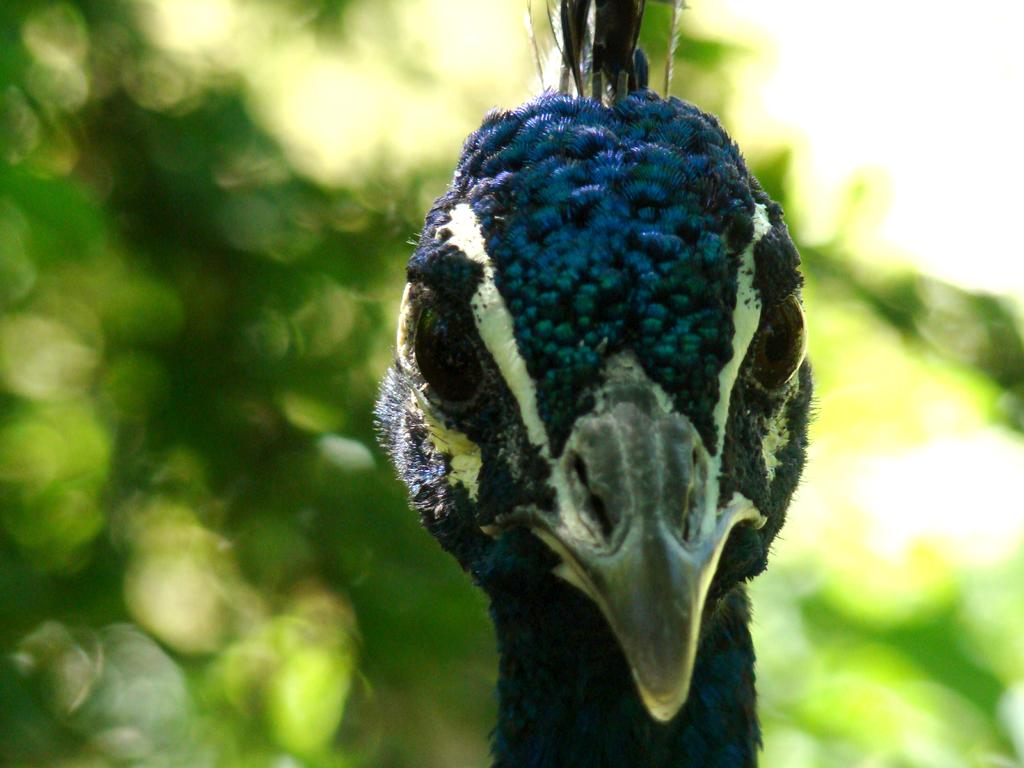What is the main subject of the image? The main subject of the image is a bird's face. Can you describe the background of the image? The background of the image is blurred. Can you tell me how many stars are visible in the image? There are no stars present in the image; it features a bird's face with a blurred background. What type of roll is being used by the stranger in the image? There is no stranger or roll present in the image. 